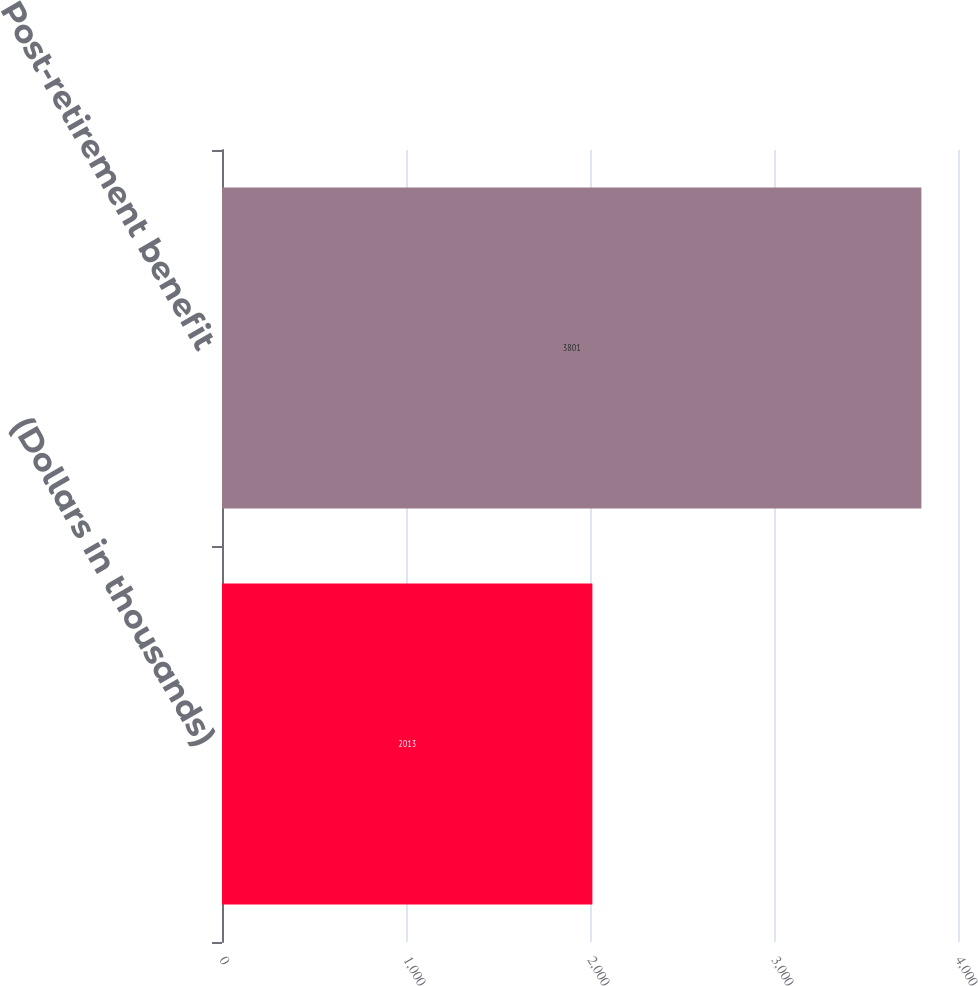Convert chart to OTSL. <chart><loc_0><loc_0><loc_500><loc_500><bar_chart><fcel>(Dollars in thousands)<fcel>Post-retirement benefit<nl><fcel>2013<fcel>3801<nl></chart> 